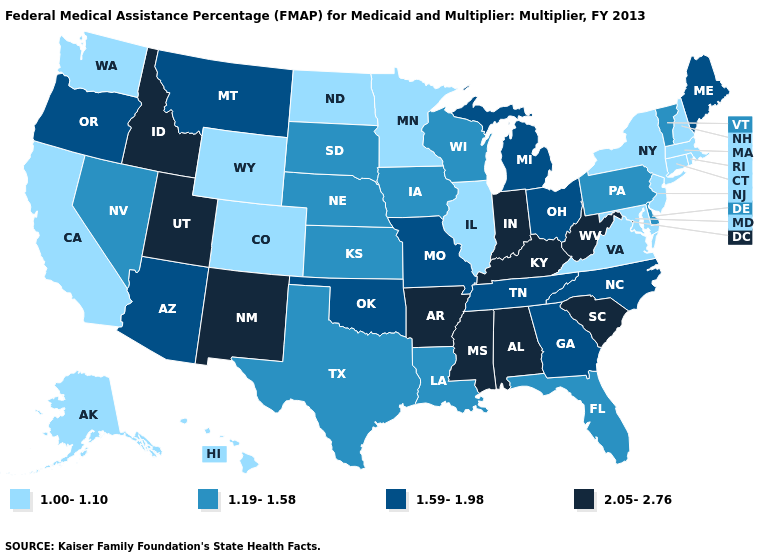Does Idaho have a higher value than California?
Give a very brief answer. Yes. Name the states that have a value in the range 1.00-1.10?
Short answer required. Alaska, California, Colorado, Connecticut, Hawaii, Illinois, Maryland, Massachusetts, Minnesota, New Hampshire, New Jersey, New York, North Dakota, Rhode Island, Virginia, Washington, Wyoming. Name the states that have a value in the range 1.19-1.58?
Short answer required. Delaware, Florida, Iowa, Kansas, Louisiana, Nebraska, Nevada, Pennsylvania, South Dakota, Texas, Vermont, Wisconsin. Which states have the highest value in the USA?
Keep it brief. Alabama, Arkansas, Idaho, Indiana, Kentucky, Mississippi, New Mexico, South Carolina, Utah, West Virginia. What is the value of Oklahoma?
Give a very brief answer. 1.59-1.98. Does West Virginia have the highest value in the USA?
Quick response, please. Yes. What is the lowest value in the USA?
Quick response, please. 1.00-1.10. How many symbols are there in the legend?
Quick response, please. 4. Does Oklahoma have the highest value in the USA?
Answer briefly. No. Name the states that have a value in the range 1.19-1.58?
Concise answer only. Delaware, Florida, Iowa, Kansas, Louisiana, Nebraska, Nevada, Pennsylvania, South Dakota, Texas, Vermont, Wisconsin. What is the value of Hawaii?
Quick response, please. 1.00-1.10. What is the value of New Mexico?
Concise answer only. 2.05-2.76. Does Massachusetts have the same value as Wyoming?
Be succinct. Yes. Name the states that have a value in the range 1.00-1.10?
Keep it brief. Alaska, California, Colorado, Connecticut, Hawaii, Illinois, Maryland, Massachusetts, Minnesota, New Hampshire, New Jersey, New York, North Dakota, Rhode Island, Virginia, Washington, Wyoming. What is the value of Nebraska?
Quick response, please. 1.19-1.58. 